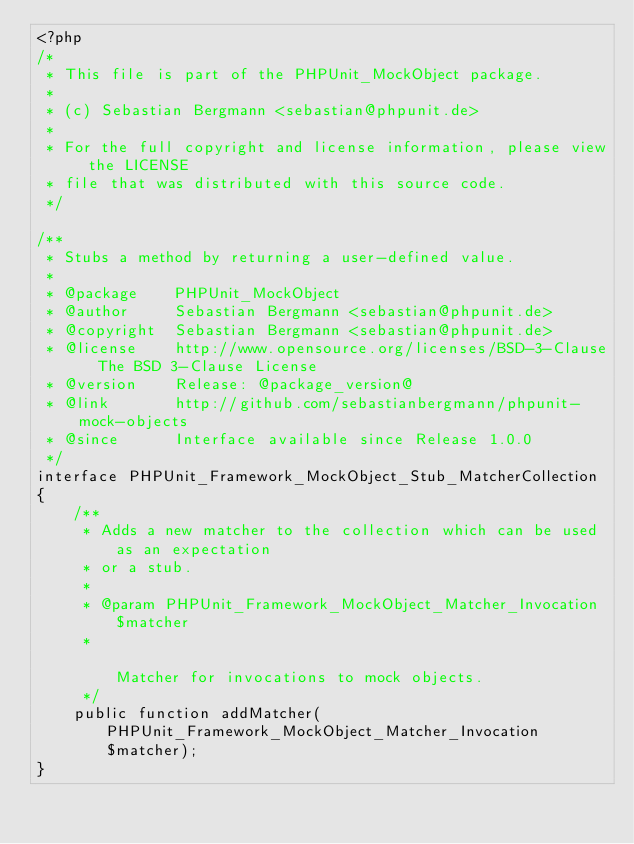Convert code to text. <code><loc_0><loc_0><loc_500><loc_500><_PHP_><?php
/*
 * This file is part of the PHPUnit_MockObject package.
 *
 * (c) Sebastian Bergmann <sebastian@phpunit.de>
 *
 * For the full copyright and license information, please view the LICENSE
 * file that was distributed with this source code.
 */

/**
 * Stubs a method by returning a user-defined value.
 *
 * @package    PHPUnit_MockObject
 * @author     Sebastian Bergmann <sebastian@phpunit.de>
 * @copyright  Sebastian Bergmann <sebastian@phpunit.de>
 * @license    http://www.opensource.org/licenses/BSD-3-Clause  The BSD 3-Clause License
 * @version    Release: @package_version@
 * @link       http://github.com/sebastianbergmann/phpunit-mock-objects
 * @since      Interface available since Release 1.0.0
 */
interface PHPUnit_Framework_MockObject_Stub_MatcherCollection
{
    /**
     * Adds a new matcher to the collection which can be used as an expectation
     * or a stub.
     *
     * @param PHPUnit_Framework_MockObject_Matcher_Invocation $matcher
     *                                                                 Matcher for invocations to mock objects.
     */
    public function addMatcher(PHPUnit_Framework_MockObject_Matcher_Invocation $matcher);
}
</code> 